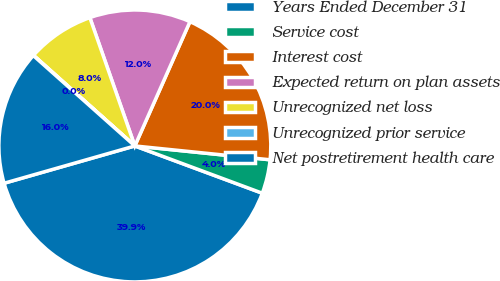<chart> <loc_0><loc_0><loc_500><loc_500><pie_chart><fcel>Years Ended December 31<fcel>Service cost<fcel>Interest cost<fcel>Expected return on plan assets<fcel>Unrecognized net loss<fcel>Unrecognized prior service<fcel>Net postretirement health care<nl><fcel>39.93%<fcel>4.03%<fcel>19.98%<fcel>12.01%<fcel>8.02%<fcel>0.04%<fcel>16.0%<nl></chart> 